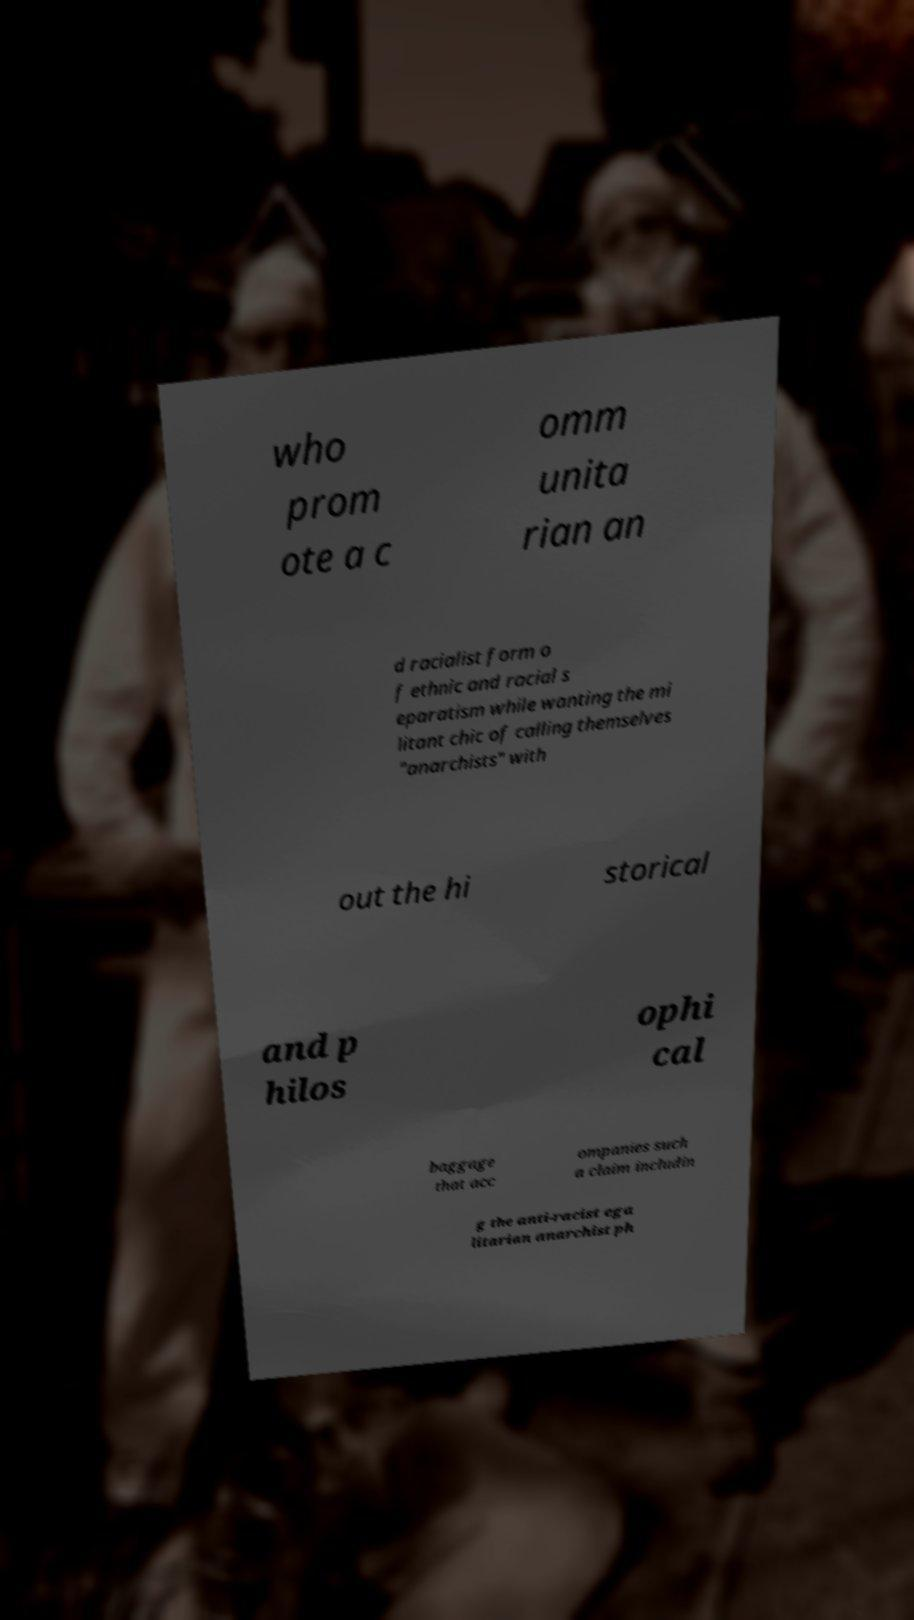For documentation purposes, I need the text within this image transcribed. Could you provide that? who prom ote a c omm unita rian an d racialist form o f ethnic and racial s eparatism while wanting the mi litant chic of calling themselves "anarchists" with out the hi storical and p hilos ophi cal baggage that acc ompanies such a claim includin g the anti-racist ega litarian anarchist ph 